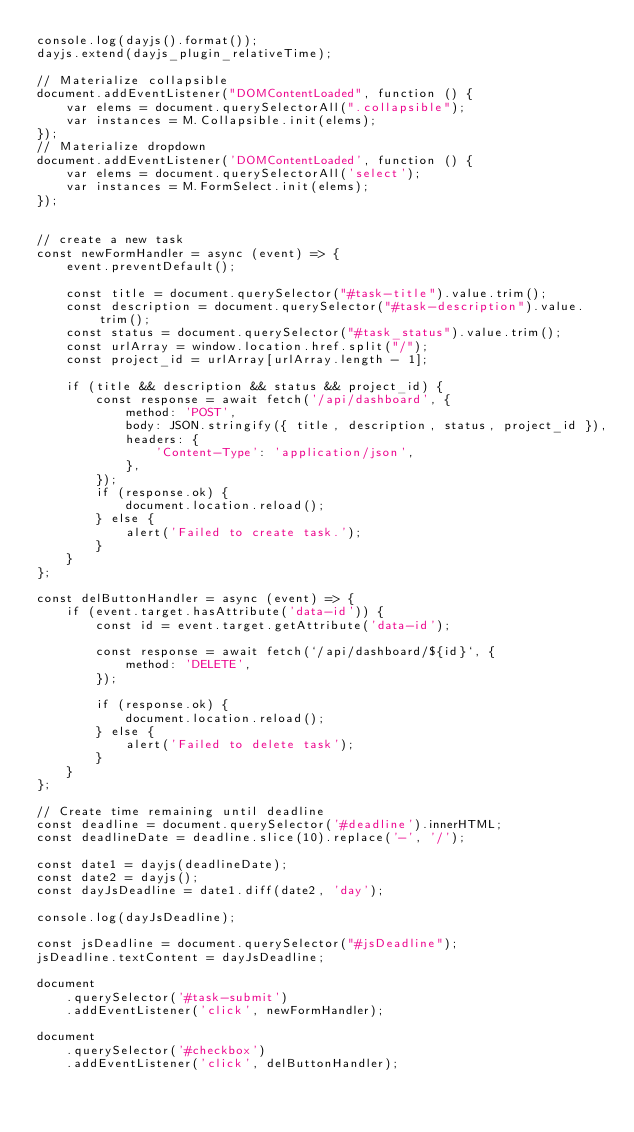<code> <loc_0><loc_0><loc_500><loc_500><_JavaScript_>console.log(dayjs().format());
dayjs.extend(dayjs_plugin_relativeTime);

// Materialize collapsible 
document.addEventListener("DOMContentLoaded", function () {
    var elems = document.querySelectorAll(".collapsible");
    var instances = M.Collapsible.init(elems);
});
// Materialize dropdown
document.addEventListener('DOMContentLoaded', function () {
    var elems = document.querySelectorAll('select');
    var instances = M.FormSelect.init(elems);
});


// create a new task
const newFormHandler = async (event) => {
    event.preventDefault();

    const title = document.querySelector("#task-title").value.trim();
    const description = document.querySelector("#task-description").value.trim();
    const status = document.querySelector("#task_status").value.trim();
    const urlArray = window.location.href.split("/");
    const project_id = urlArray[urlArray.length - 1];

    if (title && description && status && project_id) {
        const response = await fetch('/api/dashboard', {
            method: 'POST',
            body: JSON.stringify({ title, description, status, project_id }),
            headers: {
                'Content-Type': 'application/json',
            },
        });
        if (response.ok) {
            document.location.reload();
        } else {
            alert('Failed to create task.');
        }
    }
};

const delButtonHandler = async (event) => {
    if (event.target.hasAttribute('data-id')) {
        const id = event.target.getAttribute('data-id');

        const response = await fetch(`/api/dashboard/${id}`, {
            method: 'DELETE',
        });

        if (response.ok) {
            document.location.reload();
        } else {
            alert('Failed to delete task');
        }
    }
};

// Create time remaining until deadline  
const deadline = document.querySelector('#deadline').innerHTML;
const deadlineDate = deadline.slice(10).replace('-', '/');

const date1 = dayjs(deadlineDate);
const date2 = dayjs();
const dayJsDeadline = date1.diff(date2, 'day');

console.log(dayJsDeadline);

const jsDeadline = document.querySelector("#jsDeadline");
jsDeadline.textContent = dayJsDeadline;

document
    .querySelector('#task-submit')
    .addEventListener('click', newFormHandler);

document
    .querySelector('#checkbox')
    .addEventListener('click', delButtonHandler);

</code> 